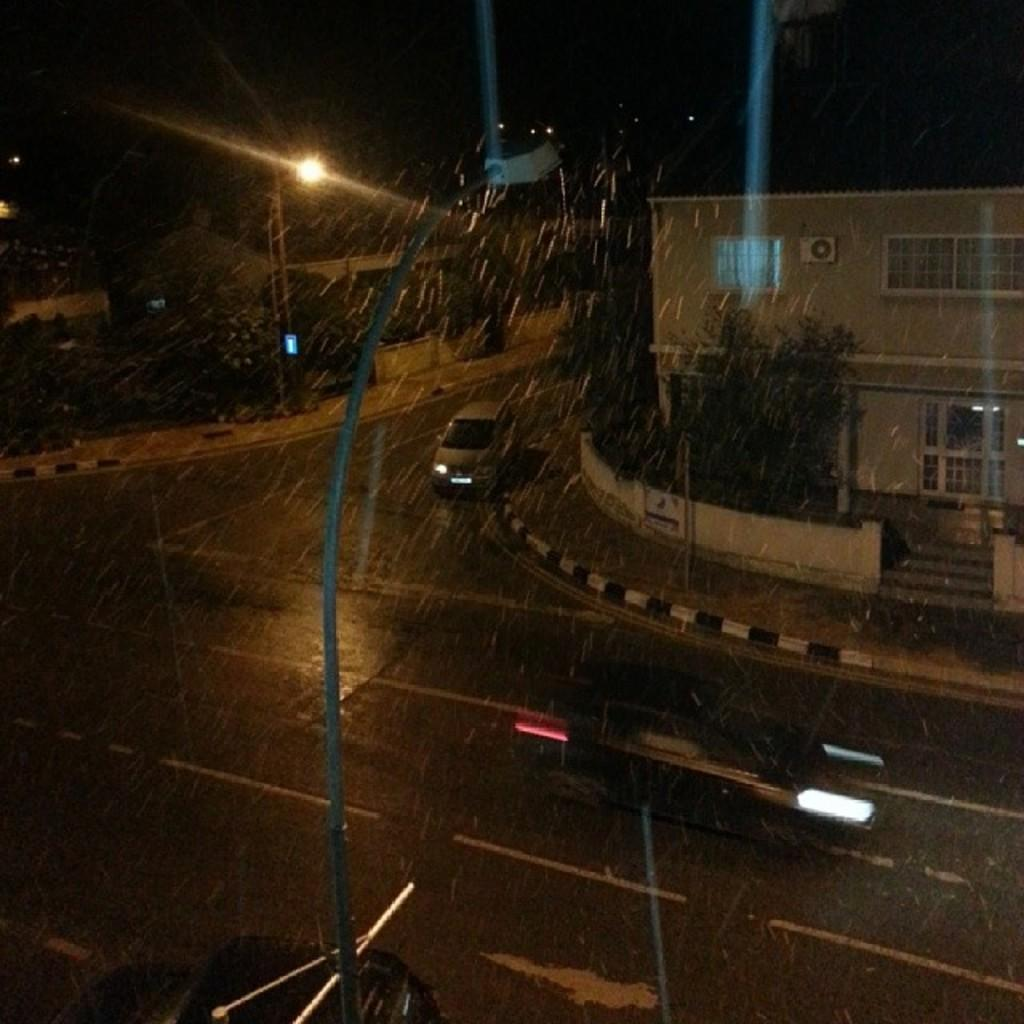What is the main object in the center of the image? There is a current pole in the center of the image. Where is the current pole located? The current pole is on the road. What can be seen in the background of the image? There are buildings, trees, vehicles, light, and the sky visible in the background of the image. What type of garden can be seen in the aftermath of the nation's celebration in the image? There is no garden, celebration, or nation mentioned in the image. The image only features a current pole on the road and various elements in the background. 